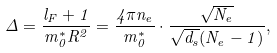<formula> <loc_0><loc_0><loc_500><loc_500>\Delta = \frac { l _ { F } + 1 } { m ^ { * } _ { 0 } R ^ { 2 } } = \frac { 4 \pi n _ { e } } { m ^ { * } _ { 0 } } \cdot \frac { \sqrt { N _ { e } } } { \sqrt { d _ { s } } ( N _ { e } - 1 ) } ,</formula> 